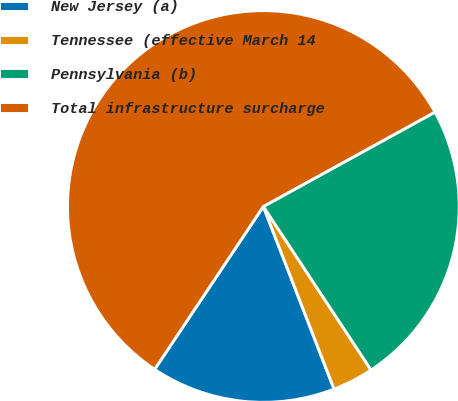Convert chart to OTSL. <chart><loc_0><loc_0><loc_500><loc_500><pie_chart><fcel>New Jersey (a)<fcel>Tennessee (effective March 14<fcel>Pennsylvania (b)<fcel>Total infrastructure surcharge<nl><fcel>15.25%<fcel>3.39%<fcel>23.73%<fcel>57.63%<nl></chart> 